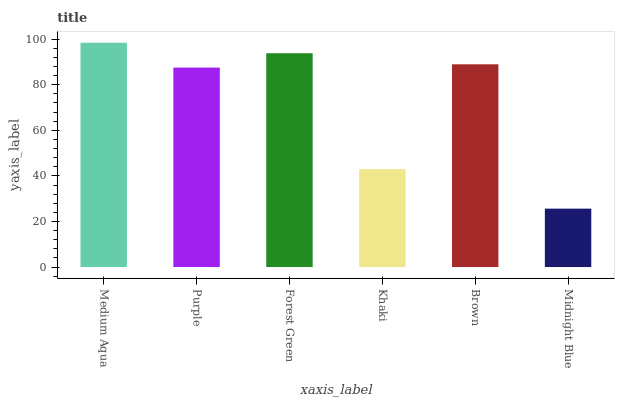Is Midnight Blue the minimum?
Answer yes or no. Yes. Is Medium Aqua the maximum?
Answer yes or no. Yes. Is Purple the minimum?
Answer yes or no. No. Is Purple the maximum?
Answer yes or no. No. Is Medium Aqua greater than Purple?
Answer yes or no. Yes. Is Purple less than Medium Aqua?
Answer yes or no. Yes. Is Purple greater than Medium Aqua?
Answer yes or no. No. Is Medium Aqua less than Purple?
Answer yes or no. No. Is Brown the high median?
Answer yes or no. Yes. Is Purple the low median?
Answer yes or no. Yes. Is Medium Aqua the high median?
Answer yes or no. No. Is Forest Green the low median?
Answer yes or no. No. 